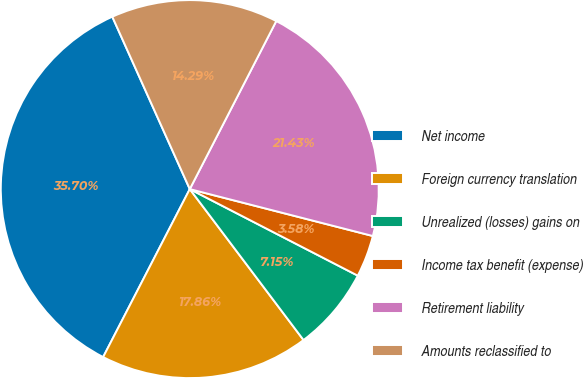Convert chart to OTSL. <chart><loc_0><loc_0><loc_500><loc_500><pie_chart><fcel>Net income<fcel>Foreign currency translation<fcel>Unrealized (losses) gains on<fcel>Income tax benefit (expense)<fcel>Retirement liability<fcel>Amounts reclassified to<nl><fcel>35.7%<fcel>17.86%<fcel>7.15%<fcel>3.58%<fcel>21.43%<fcel>14.29%<nl></chart> 